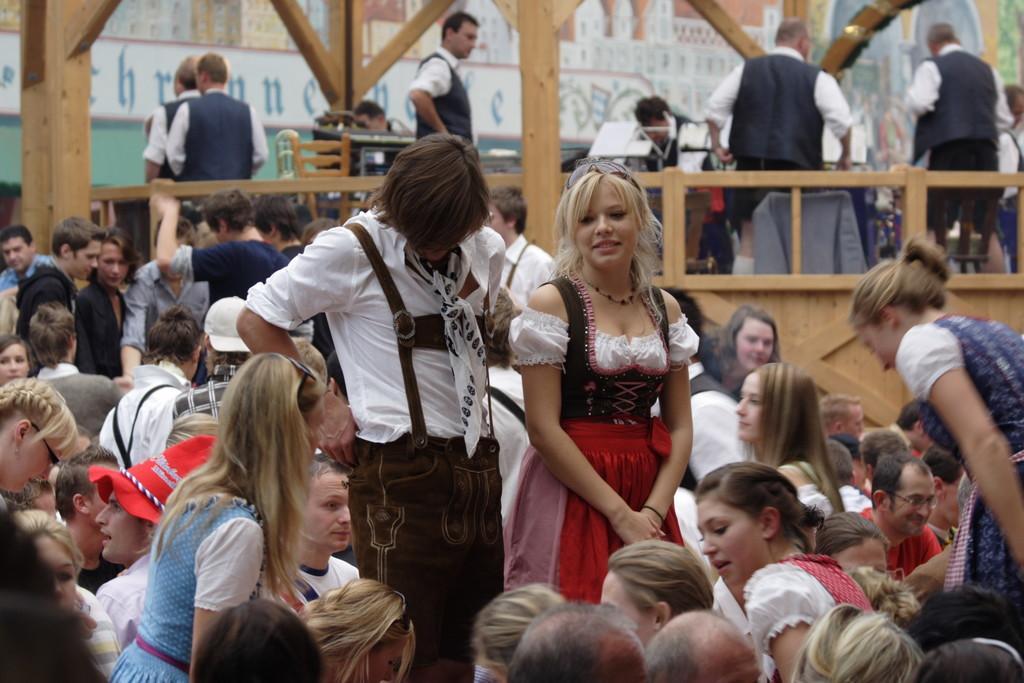In one or two sentences, can you explain what this image depicts? In this image we can see there are so many people standing and sitting, behind them there are other people standing on the wooden bridge and playing music. 